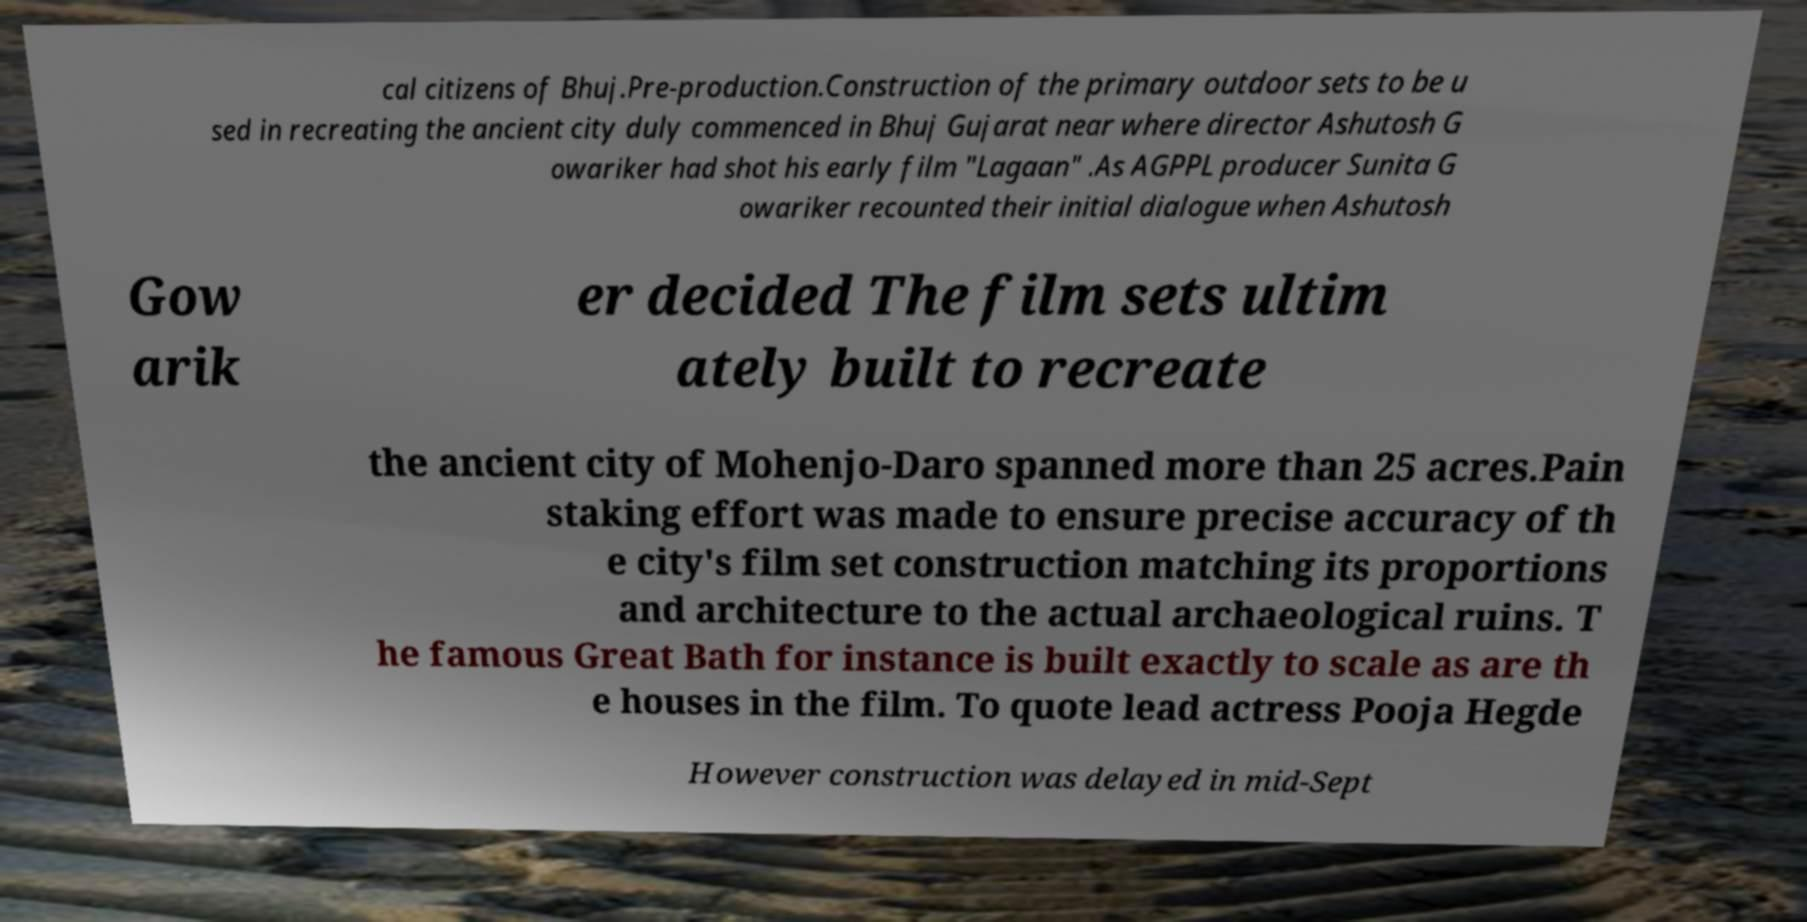What messages or text are displayed in this image? I need them in a readable, typed format. cal citizens of Bhuj.Pre-production.Construction of the primary outdoor sets to be u sed in recreating the ancient city duly commenced in Bhuj Gujarat near where director Ashutosh G owariker had shot his early film "Lagaan" .As AGPPL producer Sunita G owariker recounted their initial dialogue when Ashutosh Gow arik er decided The film sets ultim ately built to recreate the ancient city of Mohenjo-Daro spanned more than 25 acres.Pain staking effort was made to ensure precise accuracy of th e city's film set construction matching its proportions and architecture to the actual archaeological ruins. T he famous Great Bath for instance is built exactly to scale as are th e houses in the film. To quote lead actress Pooja Hegde However construction was delayed in mid-Sept 